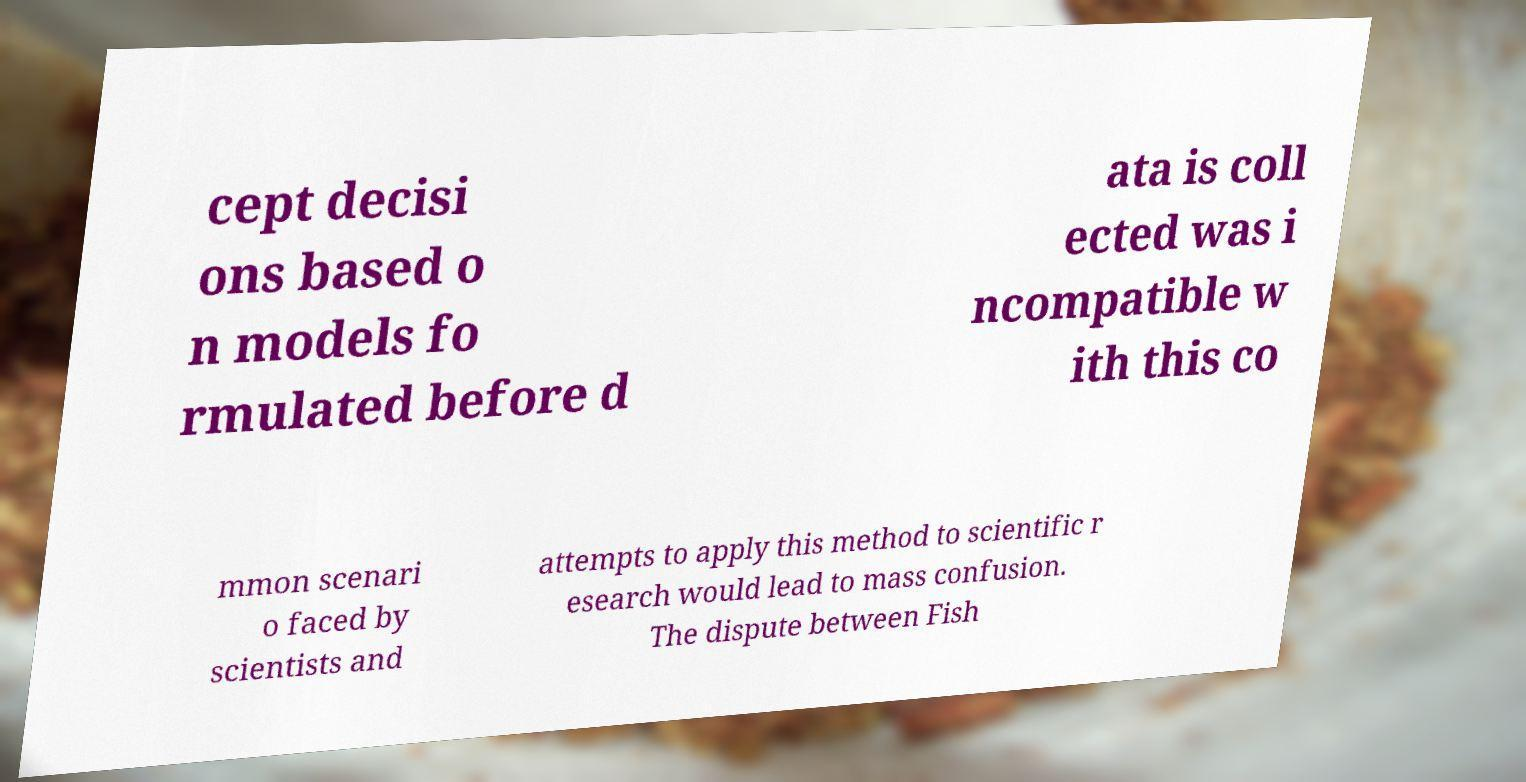Can you accurately transcribe the text from the provided image for me? cept decisi ons based o n models fo rmulated before d ata is coll ected was i ncompatible w ith this co mmon scenari o faced by scientists and attempts to apply this method to scientific r esearch would lead to mass confusion. The dispute between Fish 